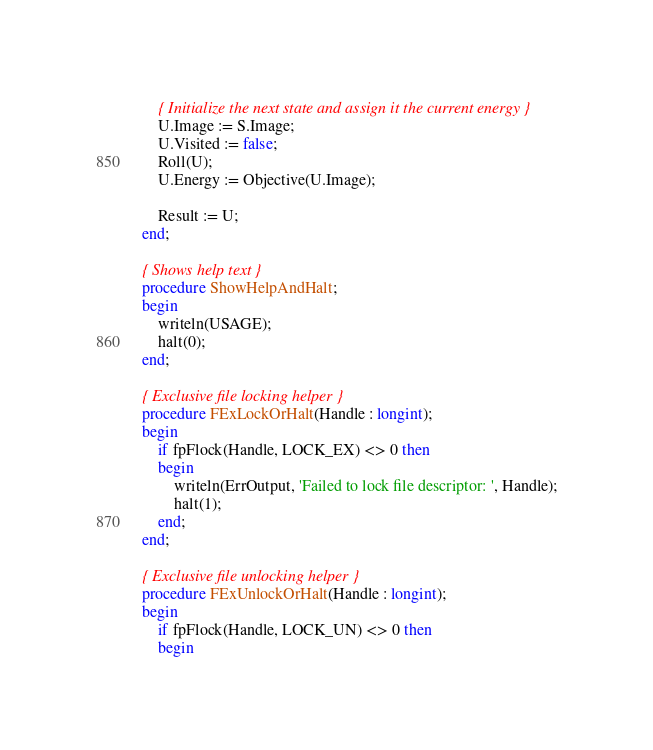Convert code to text. <code><loc_0><loc_0><loc_500><loc_500><_Pascal_>    { Initialize the next state and assign it the current energy }
    U.Image := S.Image;
    U.Visited := false;
    Roll(U);
    U.Energy := Objective(U.Image);

    Result := U;
end;

{ Shows help text }
procedure ShowHelpAndHalt;
begin
    writeln(USAGE);
    halt(0);
end;

{ Exclusive file locking helper }
procedure FExLockOrHalt(Handle : longint);
begin
    if fpFlock(Handle, LOCK_EX) <> 0 then
    begin
        writeln(ErrOutput, 'Failed to lock file descriptor: ', Handle);
        halt(1);
    end;
end;

{ Exclusive file unlocking helper }
procedure FExUnlockOrHalt(Handle : longint);
begin
    if fpFlock(Handle, LOCK_UN) <> 0 then
    begin</code> 